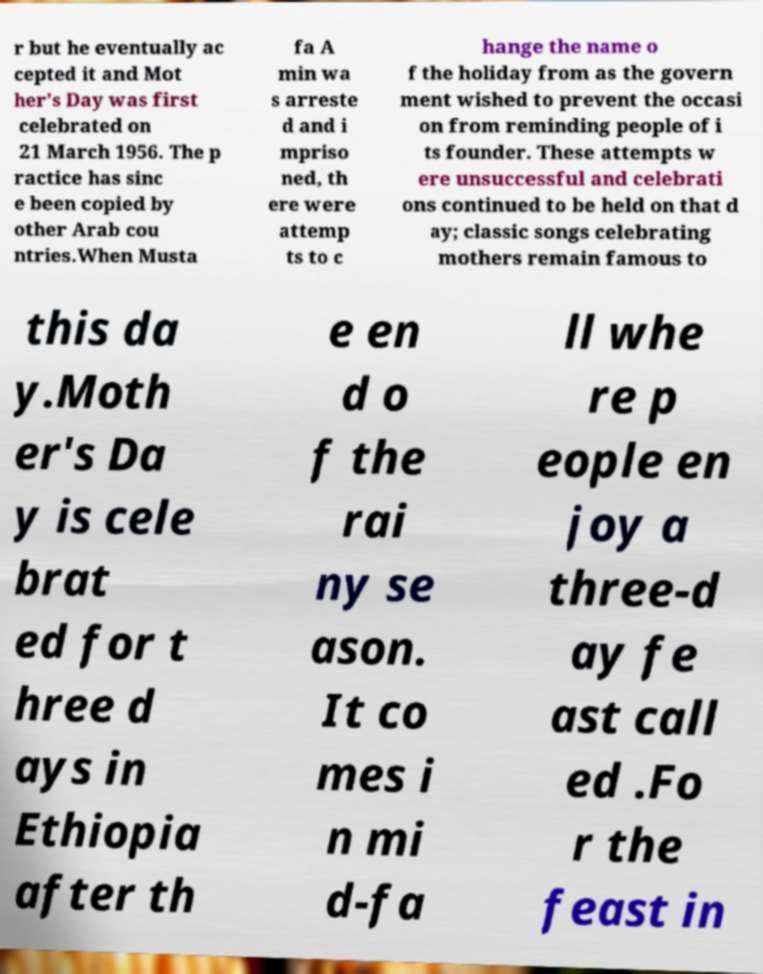What messages or text are displayed in this image? I need them in a readable, typed format. r but he eventually ac cepted it and Mot her's Day was first celebrated on 21 March 1956. The p ractice has sinc e been copied by other Arab cou ntries.When Musta fa A min wa s arreste d and i mpriso ned, th ere were attemp ts to c hange the name o f the holiday from as the govern ment wished to prevent the occasi on from reminding people of i ts founder. These attempts w ere unsuccessful and celebrati ons continued to be held on that d ay; classic songs celebrating mothers remain famous to this da y.Moth er's Da y is cele brat ed for t hree d ays in Ethiopia after th e en d o f the rai ny se ason. It co mes i n mi d-fa ll whe re p eople en joy a three-d ay fe ast call ed .Fo r the feast in 